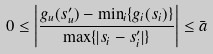Convert formula to latex. <formula><loc_0><loc_0><loc_500><loc_500>0 \leq \left | \frac { g _ { u } ( s ^ { \prime } _ { u } ) - \min _ { i } \{ g _ { i } ( s _ { i } ) \} } { \max \{ | s _ { i } - s ^ { \prime } _ { i } | \} } \right | \leq \bar { a }</formula> 